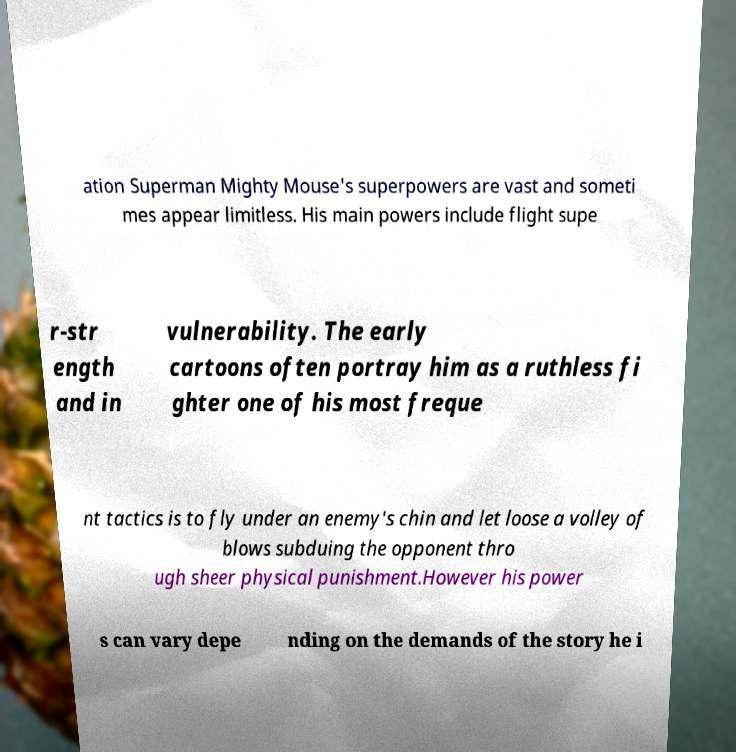I need the written content from this picture converted into text. Can you do that? ation Superman Mighty Mouse's superpowers are vast and someti mes appear limitless. His main powers include flight supe r-str ength and in vulnerability. The early cartoons often portray him as a ruthless fi ghter one of his most freque nt tactics is to fly under an enemy's chin and let loose a volley of blows subduing the opponent thro ugh sheer physical punishment.However his power s can vary depe nding on the demands of the story he i 